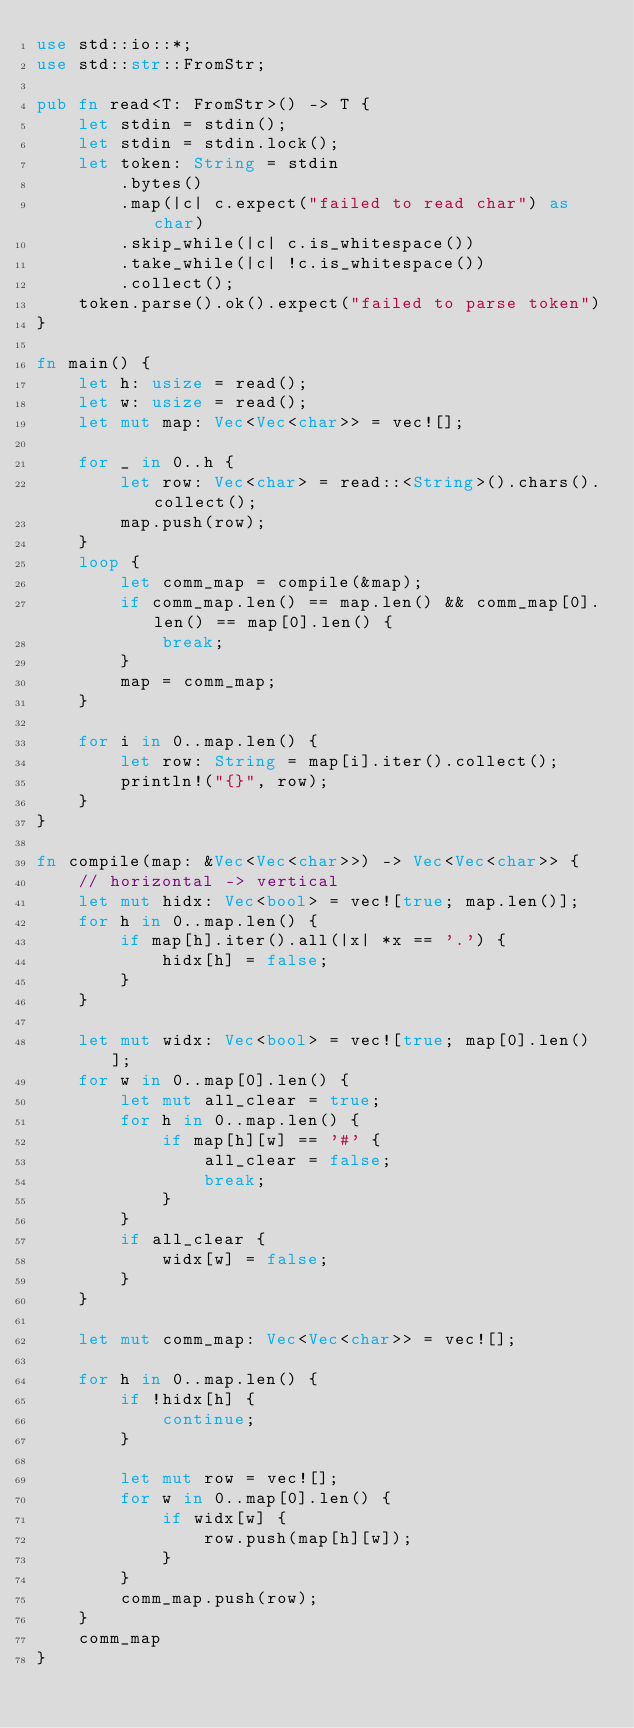<code> <loc_0><loc_0><loc_500><loc_500><_Rust_>use std::io::*;
use std::str::FromStr;

pub fn read<T: FromStr>() -> T {
    let stdin = stdin();
    let stdin = stdin.lock();
    let token: String = stdin
        .bytes()
        .map(|c| c.expect("failed to read char") as char)
        .skip_while(|c| c.is_whitespace())
        .take_while(|c| !c.is_whitespace())
        .collect();
    token.parse().ok().expect("failed to parse token")
}

fn main() {
    let h: usize = read();
    let w: usize = read();
    let mut map: Vec<Vec<char>> = vec![];

    for _ in 0..h {
        let row: Vec<char> = read::<String>().chars().collect();
        map.push(row);
    }
    loop {
        let comm_map = compile(&map);
        if comm_map.len() == map.len() && comm_map[0].len() == map[0].len() {
            break;
        }
        map = comm_map;
    }

    for i in 0..map.len() {
        let row: String = map[i].iter().collect();
        println!("{}", row);
    }
}

fn compile(map: &Vec<Vec<char>>) -> Vec<Vec<char>> {
    // horizontal -> vertical
    let mut hidx: Vec<bool> = vec![true; map.len()];
    for h in 0..map.len() {
        if map[h].iter().all(|x| *x == '.') {
            hidx[h] = false;
        }
    }

    let mut widx: Vec<bool> = vec![true; map[0].len()];
    for w in 0..map[0].len() {
        let mut all_clear = true;
        for h in 0..map.len() {
            if map[h][w] == '#' {
                all_clear = false;
                break;
            }
        }
        if all_clear {
            widx[w] = false;
        }
    }

    let mut comm_map: Vec<Vec<char>> = vec![];

    for h in 0..map.len() {
        if !hidx[h] {
            continue;
        }

        let mut row = vec![];
        for w in 0..map[0].len() {
            if widx[w] {
                row.push(map[h][w]);
            }
        }
        comm_map.push(row);
    }
    comm_map
}
</code> 